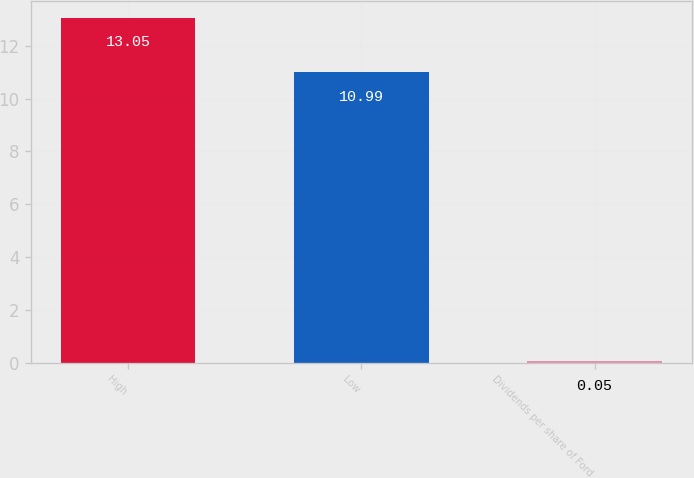Convert chart to OTSL. <chart><loc_0><loc_0><loc_500><loc_500><bar_chart><fcel>High<fcel>Low<fcel>Dividends per share of Ford<nl><fcel>13.05<fcel>10.99<fcel>0.05<nl></chart> 